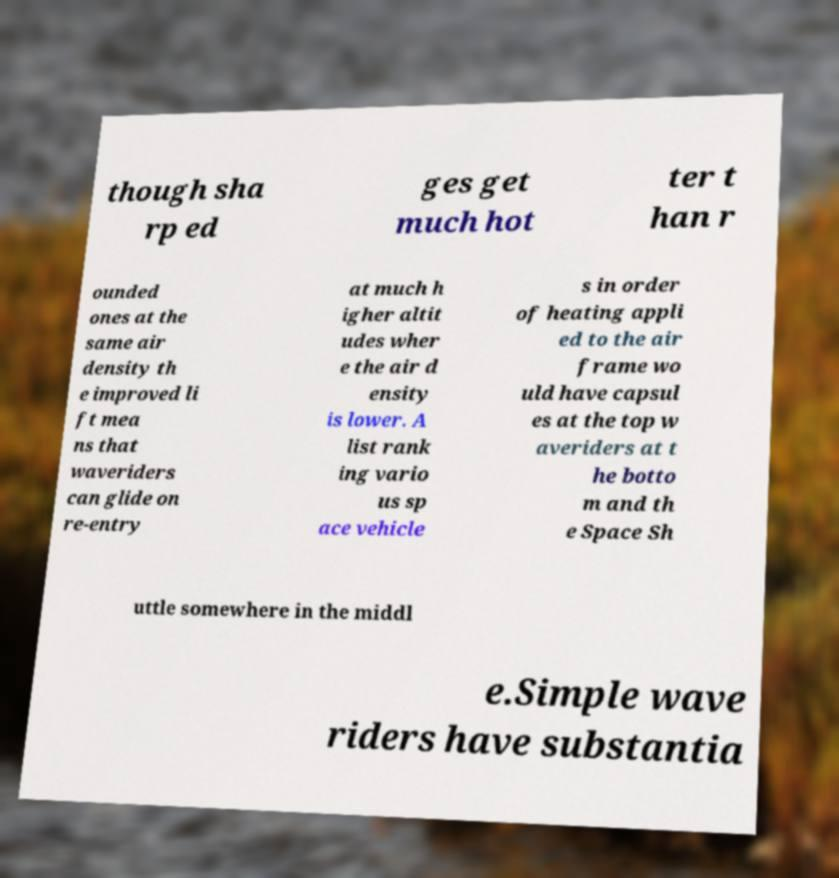Could you extract and type out the text from this image? though sha rp ed ges get much hot ter t han r ounded ones at the same air density th e improved li ft mea ns that waveriders can glide on re-entry at much h igher altit udes wher e the air d ensity is lower. A list rank ing vario us sp ace vehicle s in order of heating appli ed to the air frame wo uld have capsul es at the top w averiders at t he botto m and th e Space Sh uttle somewhere in the middl e.Simple wave riders have substantia 